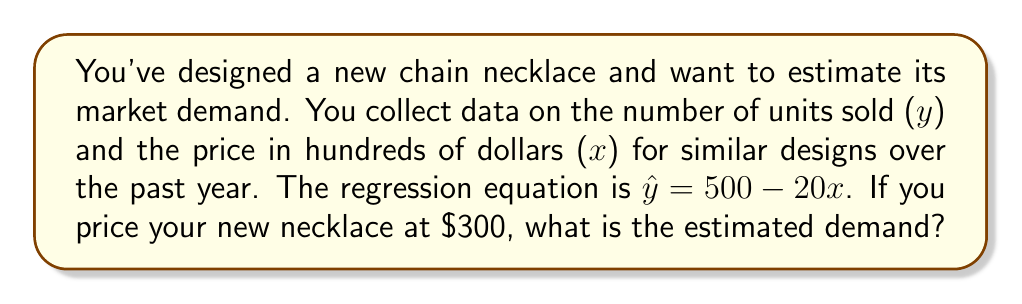Provide a solution to this math problem. To solve this problem, we'll follow these steps:

1. Understand the given regression equation:
   $\hat{y} = 500 - 20x$
   Where $\hat{y}$ is the estimated demand (units sold) and $x$ is the price in hundreds of dollars.

2. Convert the given price to hundreds of dollars:
   $300 = 3$ hundred dollars
   So, $x = 3$

3. Substitute $x = 3$ into the regression equation:
   $\hat{y} = 500 - 20(3)$
   $\hat{y} = 500 - 60$
   $\hat{y} = 440$

4. Interpret the result:
   The estimated demand for the new necklace priced at $300 is 440 units.
Answer: 440 units 